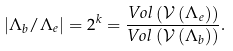<formula> <loc_0><loc_0><loc_500><loc_500>\left | \Lambda _ { b } / \Lambda _ { e } \right | = 2 ^ { k } = \frac { V o l \left ( \mathcal { V } \left ( \Lambda _ { e } \right ) \right ) } { V o l \left ( \mathcal { V } \left ( \Lambda _ { b } \right ) \right ) } .</formula> 